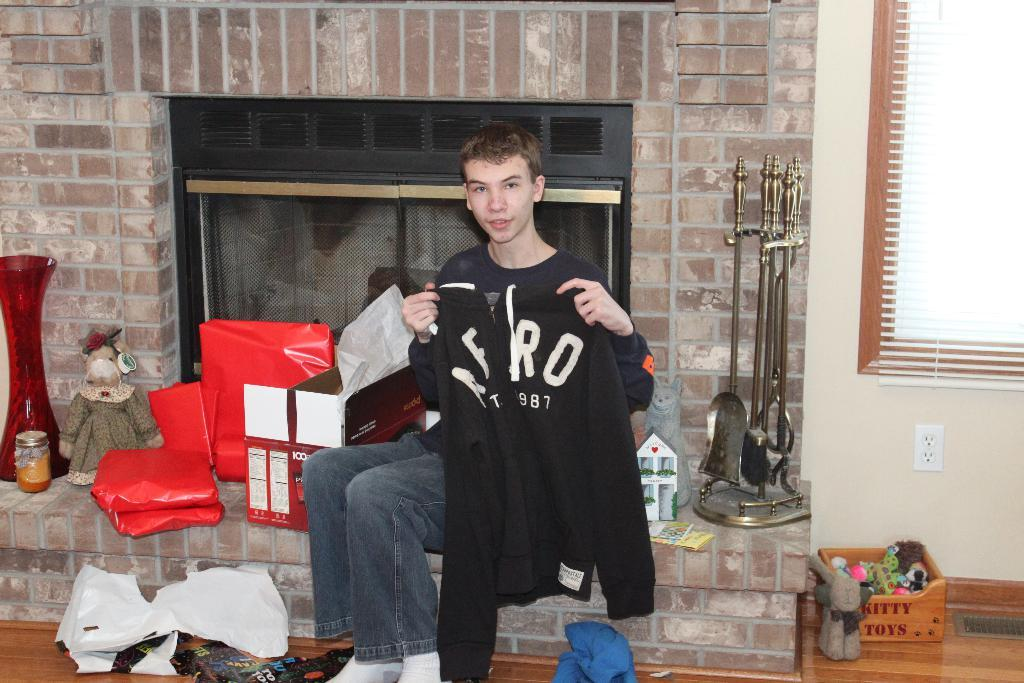<image>
Write a terse but informative summary of the picture. a person that has a sweatshirt with the word aero on it 